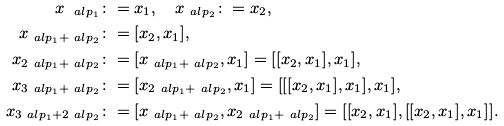Convert formula to latex. <formula><loc_0><loc_0><loc_500><loc_500>x _ { \ a l p _ { 1 } } & \colon = x _ { 1 } , \quad x _ { \ a l p _ { 2 } } \colon = x _ { 2 } , \\ x _ { \ a l p _ { 1 } + \ a l p _ { 2 } } & \colon = [ x _ { 2 } , x _ { 1 } ] , \\ x _ { 2 \ a l p _ { 1 } + \ a l p _ { 2 } } & \colon = [ x _ { \ a l p _ { 1 } + \ a l p _ { 2 } } , x _ { 1 } ] = [ [ x _ { 2 } , x _ { 1 } ] , x _ { 1 } ] , \\ x _ { 3 \ a l p _ { 1 } + \ a l p _ { 2 } } & \colon = [ x _ { 2 \ a l p _ { 1 } + \ a l p _ { 2 } } , x _ { 1 } ] = [ [ [ x _ { 2 } , x _ { 1 } ] , x _ { 1 } ] , x _ { 1 } ] , \\ x _ { 3 \ a l p _ { 1 } + 2 \ a l p _ { 2 } } & \colon = [ x _ { \ a l p _ { 1 } + \ a l p _ { 2 } } , x _ { 2 \ a l p _ { 1 } + \ a l p _ { 2 } } ] = [ [ x _ { 2 } , x _ { 1 } ] , [ [ x _ { 2 } , x _ { 1 } ] , x _ { 1 } ] ] .</formula> 